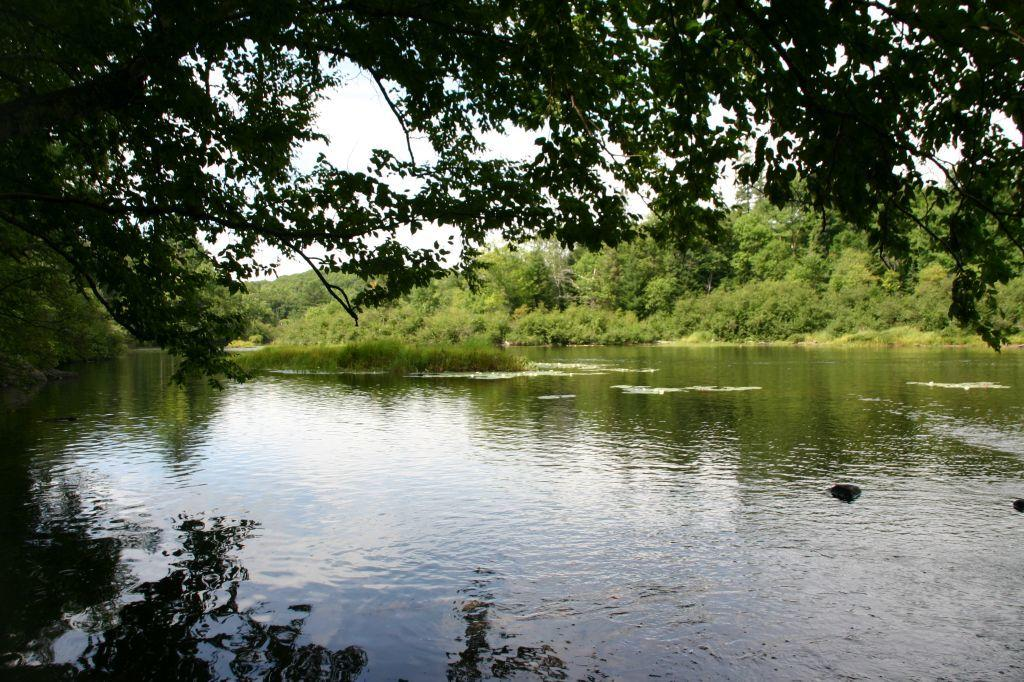What is the main feature of the image? There is a large water body in the image. What else can be seen in the image besides the water body? Plants and a group of trees are visible in the image. What is visible in the background of the image? The sky is visible in the image. How would you describe the sky in the image? The sky appears to be cloudy. Where is the vase placed in the image? There is no vase present in the image. What type of cushion can be seen on the stage in the image? There is no stage or cushion present in the image. 